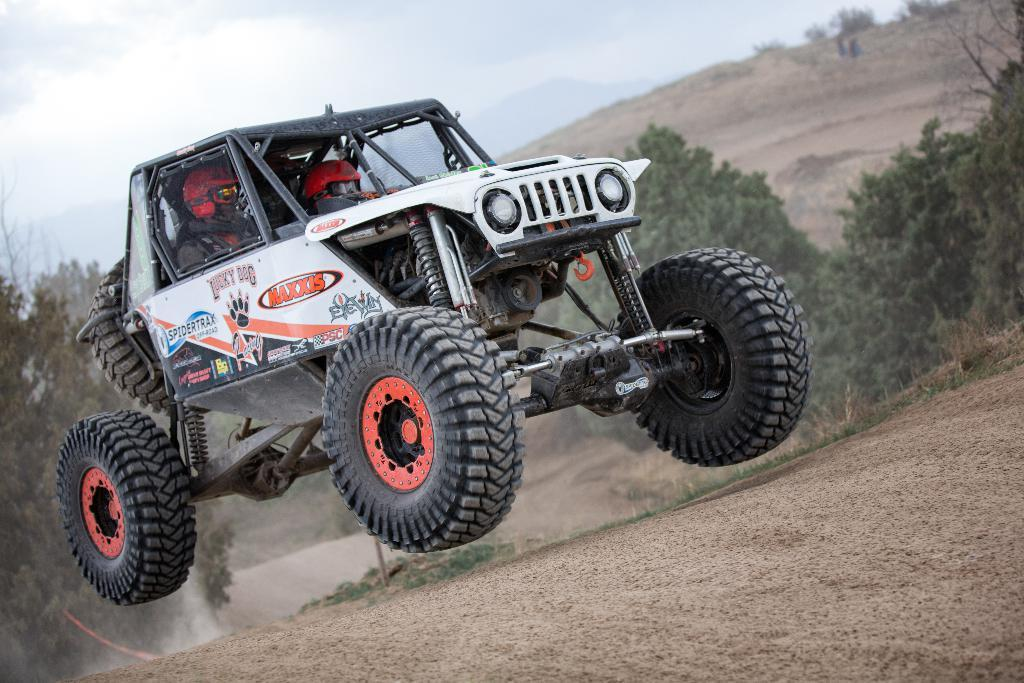How many people are in the image? There are two persons in the image. What are the persons doing in the image? The persons are sitting on the seats of a vehicle. What is the vehicle doing in the image? The vehicle is jumping on the road. What can be seen in the background of the image? There are trees, mountains, and clouds in the sky in the background of the image. What type of jail can be seen in the image? There is no jail present in the image. How is the distribution of the mountain in the image? The image does not show the distribution of the mountain; it only shows the mountain in the background. 